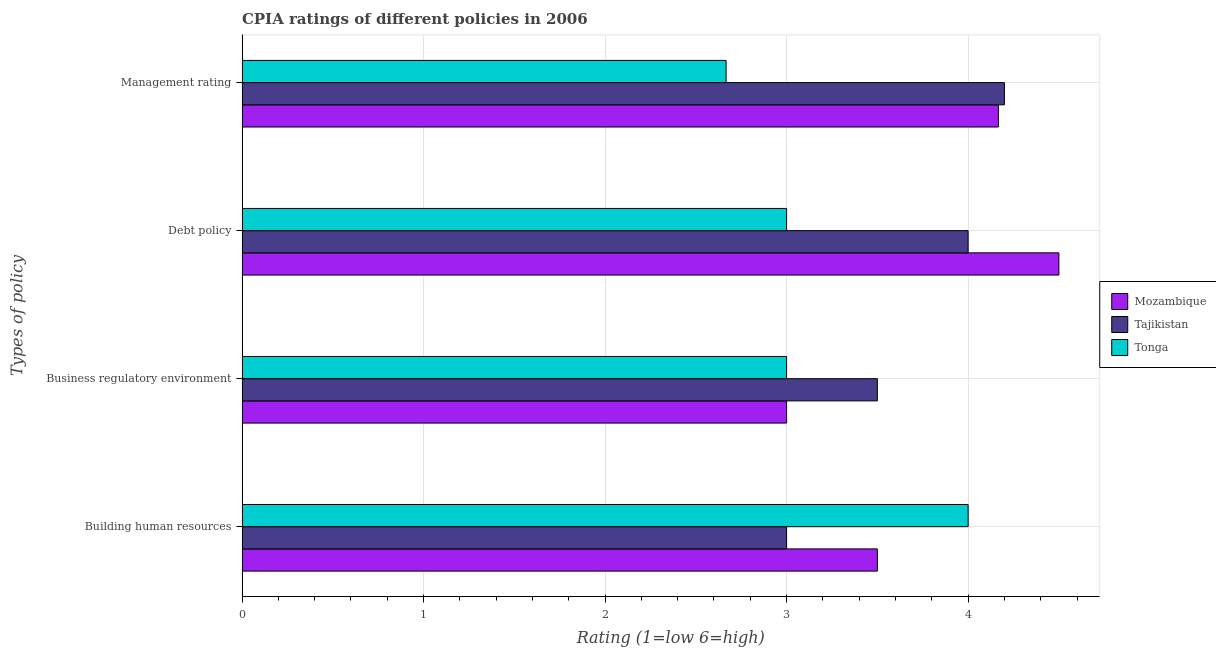How many different coloured bars are there?
Offer a very short reply. 3. How many bars are there on the 3rd tick from the top?
Offer a terse response. 3. How many bars are there on the 3rd tick from the bottom?
Offer a terse response. 3. What is the label of the 4th group of bars from the top?
Make the answer very short. Building human resources. Across all countries, what is the maximum cpia rating of management?
Ensure brevity in your answer.  4.2. In which country was the cpia rating of debt policy maximum?
Your answer should be compact. Mozambique. In which country was the cpia rating of building human resources minimum?
Offer a terse response. Tajikistan. What is the total cpia rating of building human resources in the graph?
Give a very brief answer. 10.5. What is the average cpia rating of building human resources per country?
Your response must be concise. 3.5. What is the difference between the cpia rating of business regulatory environment and cpia rating of management in Tonga?
Give a very brief answer. 0.33. What is the ratio of the cpia rating of business regulatory environment in Tonga to that in Tajikistan?
Your answer should be compact. 0.86. Is the cpia rating of building human resources in Tonga less than that in Tajikistan?
Give a very brief answer. No. Is the difference between the cpia rating of business regulatory environment in Tonga and Mozambique greater than the difference between the cpia rating of building human resources in Tonga and Mozambique?
Your answer should be compact. No. What is the difference between the highest and the lowest cpia rating of management?
Your answer should be compact. 1.53. In how many countries, is the cpia rating of business regulatory environment greater than the average cpia rating of business regulatory environment taken over all countries?
Offer a very short reply. 1. What does the 3rd bar from the top in Building human resources represents?
Your answer should be very brief. Mozambique. What does the 1st bar from the bottom in Debt policy represents?
Provide a short and direct response. Mozambique. How many bars are there?
Give a very brief answer. 12. Are all the bars in the graph horizontal?
Your response must be concise. Yes. Are the values on the major ticks of X-axis written in scientific E-notation?
Make the answer very short. No. Does the graph contain any zero values?
Your answer should be compact. No. How are the legend labels stacked?
Keep it short and to the point. Vertical. What is the title of the graph?
Your answer should be compact. CPIA ratings of different policies in 2006. What is the label or title of the Y-axis?
Your answer should be very brief. Types of policy. What is the Rating (1=low 6=high) of Tonga in Building human resources?
Provide a short and direct response. 4. What is the Rating (1=low 6=high) of Mozambique in Business regulatory environment?
Offer a very short reply. 3. What is the Rating (1=low 6=high) of Mozambique in Debt policy?
Give a very brief answer. 4.5. What is the Rating (1=low 6=high) in Tonga in Debt policy?
Give a very brief answer. 3. What is the Rating (1=low 6=high) in Mozambique in Management rating?
Provide a succinct answer. 4.17. What is the Rating (1=low 6=high) in Tonga in Management rating?
Ensure brevity in your answer.  2.67. Across all Types of policy, what is the maximum Rating (1=low 6=high) of Mozambique?
Your answer should be compact. 4.5. Across all Types of policy, what is the maximum Rating (1=low 6=high) of Tajikistan?
Offer a very short reply. 4.2. Across all Types of policy, what is the maximum Rating (1=low 6=high) in Tonga?
Your answer should be very brief. 4. Across all Types of policy, what is the minimum Rating (1=low 6=high) in Tonga?
Your response must be concise. 2.67. What is the total Rating (1=low 6=high) in Mozambique in the graph?
Keep it short and to the point. 15.17. What is the total Rating (1=low 6=high) of Tajikistan in the graph?
Offer a terse response. 14.7. What is the total Rating (1=low 6=high) in Tonga in the graph?
Make the answer very short. 12.67. What is the difference between the Rating (1=low 6=high) in Tajikistan in Building human resources and that in Business regulatory environment?
Make the answer very short. -0.5. What is the difference between the Rating (1=low 6=high) of Tonga in Building human resources and that in Business regulatory environment?
Your response must be concise. 1. What is the difference between the Rating (1=low 6=high) in Mozambique in Building human resources and that in Debt policy?
Make the answer very short. -1. What is the difference between the Rating (1=low 6=high) in Mozambique in Building human resources and that in Management rating?
Your response must be concise. -0.67. What is the difference between the Rating (1=low 6=high) in Tajikistan in Building human resources and that in Management rating?
Offer a terse response. -1.2. What is the difference between the Rating (1=low 6=high) in Tonga in Building human resources and that in Management rating?
Make the answer very short. 1.33. What is the difference between the Rating (1=low 6=high) of Tajikistan in Business regulatory environment and that in Debt policy?
Make the answer very short. -0.5. What is the difference between the Rating (1=low 6=high) in Mozambique in Business regulatory environment and that in Management rating?
Offer a terse response. -1.17. What is the difference between the Rating (1=low 6=high) in Tajikistan in Debt policy and that in Management rating?
Make the answer very short. -0.2. What is the difference between the Rating (1=low 6=high) in Tonga in Debt policy and that in Management rating?
Make the answer very short. 0.33. What is the difference between the Rating (1=low 6=high) of Mozambique in Building human resources and the Rating (1=low 6=high) of Tajikistan in Business regulatory environment?
Make the answer very short. 0. What is the difference between the Rating (1=low 6=high) of Tajikistan in Building human resources and the Rating (1=low 6=high) of Tonga in Business regulatory environment?
Provide a short and direct response. 0. What is the difference between the Rating (1=low 6=high) in Mozambique in Building human resources and the Rating (1=low 6=high) in Tajikistan in Debt policy?
Offer a very short reply. -0.5. What is the difference between the Rating (1=low 6=high) in Mozambique in Building human resources and the Rating (1=low 6=high) in Tonga in Debt policy?
Provide a short and direct response. 0.5. What is the difference between the Rating (1=low 6=high) of Tajikistan in Building human resources and the Rating (1=low 6=high) of Tonga in Debt policy?
Provide a short and direct response. 0. What is the difference between the Rating (1=low 6=high) of Mozambique in Building human resources and the Rating (1=low 6=high) of Tajikistan in Management rating?
Your answer should be compact. -0.7. What is the difference between the Rating (1=low 6=high) in Tajikistan in Building human resources and the Rating (1=low 6=high) in Tonga in Management rating?
Provide a short and direct response. 0.33. What is the difference between the Rating (1=low 6=high) in Tajikistan in Business regulatory environment and the Rating (1=low 6=high) in Tonga in Debt policy?
Offer a terse response. 0.5. What is the difference between the Rating (1=low 6=high) of Tajikistan in Business regulatory environment and the Rating (1=low 6=high) of Tonga in Management rating?
Ensure brevity in your answer.  0.83. What is the difference between the Rating (1=low 6=high) of Mozambique in Debt policy and the Rating (1=low 6=high) of Tonga in Management rating?
Offer a very short reply. 1.83. What is the average Rating (1=low 6=high) in Mozambique per Types of policy?
Ensure brevity in your answer.  3.79. What is the average Rating (1=low 6=high) in Tajikistan per Types of policy?
Your response must be concise. 3.67. What is the average Rating (1=low 6=high) in Tonga per Types of policy?
Keep it short and to the point. 3.17. What is the difference between the Rating (1=low 6=high) of Mozambique and Rating (1=low 6=high) of Tonga in Building human resources?
Provide a short and direct response. -0.5. What is the difference between the Rating (1=low 6=high) in Tajikistan and Rating (1=low 6=high) in Tonga in Building human resources?
Your answer should be very brief. -1. What is the difference between the Rating (1=low 6=high) in Mozambique and Rating (1=low 6=high) in Tajikistan in Business regulatory environment?
Your answer should be very brief. -0.5. What is the difference between the Rating (1=low 6=high) of Mozambique and Rating (1=low 6=high) of Tajikistan in Debt policy?
Give a very brief answer. 0.5. What is the difference between the Rating (1=low 6=high) of Tajikistan and Rating (1=low 6=high) of Tonga in Debt policy?
Provide a short and direct response. 1. What is the difference between the Rating (1=low 6=high) in Mozambique and Rating (1=low 6=high) in Tajikistan in Management rating?
Provide a succinct answer. -0.03. What is the difference between the Rating (1=low 6=high) of Mozambique and Rating (1=low 6=high) of Tonga in Management rating?
Your answer should be compact. 1.5. What is the difference between the Rating (1=low 6=high) in Tajikistan and Rating (1=low 6=high) in Tonga in Management rating?
Provide a succinct answer. 1.53. What is the ratio of the Rating (1=low 6=high) in Tonga in Building human resources to that in Business regulatory environment?
Make the answer very short. 1.33. What is the ratio of the Rating (1=low 6=high) in Mozambique in Building human resources to that in Debt policy?
Offer a terse response. 0.78. What is the ratio of the Rating (1=low 6=high) in Tajikistan in Building human resources to that in Debt policy?
Make the answer very short. 0.75. What is the ratio of the Rating (1=low 6=high) in Mozambique in Building human resources to that in Management rating?
Keep it short and to the point. 0.84. What is the ratio of the Rating (1=low 6=high) of Tajikistan in Building human resources to that in Management rating?
Make the answer very short. 0.71. What is the ratio of the Rating (1=low 6=high) in Tonga in Building human resources to that in Management rating?
Ensure brevity in your answer.  1.5. What is the ratio of the Rating (1=low 6=high) of Mozambique in Business regulatory environment to that in Management rating?
Your answer should be compact. 0.72. What is the ratio of the Rating (1=low 6=high) of Mozambique in Debt policy to that in Management rating?
Your response must be concise. 1.08. What is the ratio of the Rating (1=low 6=high) of Tajikistan in Debt policy to that in Management rating?
Make the answer very short. 0.95. What is the ratio of the Rating (1=low 6=high) of Tonga in Debt policy to that in Management rating?
Provide a succinct answer. 1.12. What is the difference between the highest and the second highest Rating (1=low 6=high) in Tajikistan?
Provide a short and direct response. 0.2. What is the difference between the highest and the second highest Rating (1=low 6=high) in Tonga?
Keep it short and to the point. 1. What is the difference between the highest and the lowest Rating (1=low 6=high) in Tajikistan?
Offer a very short reply. 1.2. 